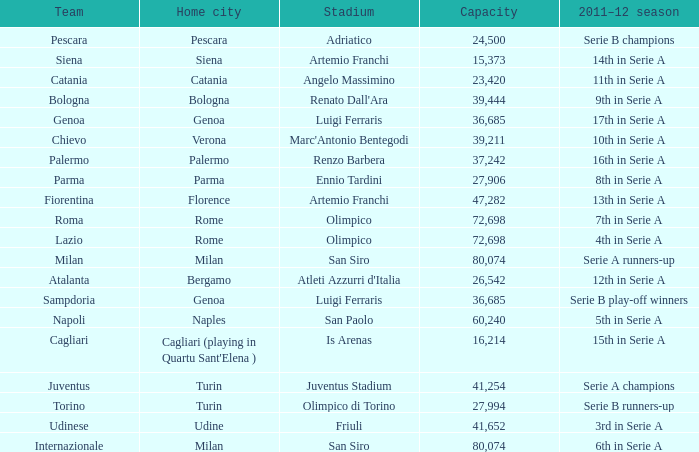What is the home city for angelo massimino stadium? Catania. 